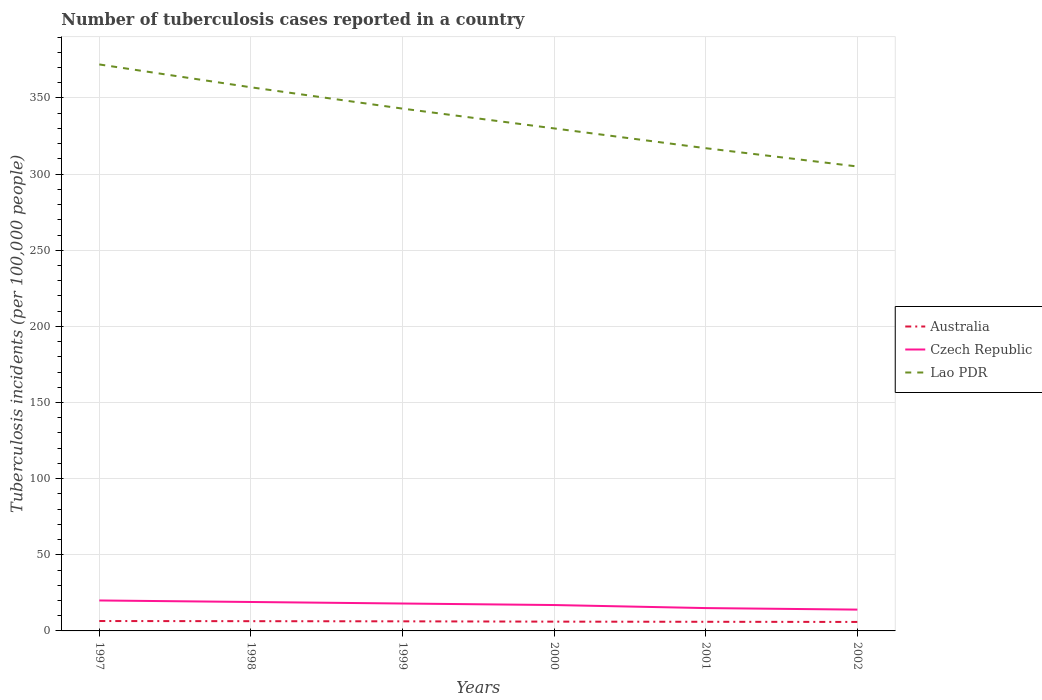Is the number of lines equal to the number of legend labels?
Your response must be concise. Yes. Across all years, what is the maximum number of tuberculosis cases reported in in Czech Republic?
Your answer should be very brief. 14. What is the total number of tuberculosis cases reported in in Australia in the graph?
Give a very brief answer. 0.2. What is the difference between the highest and the second highest number of tuberculosis cases reported in in Czech Republic?
Your answer should be compact. 6. How many years are there in the graph?
Keep it short and to the point. 6. What is the difference between two consecutive major ticks on the Y-axis?
Provide a succinct answer. 50. Where does the legend appear in the graph?
Your answer should be compact. Center right. How many legend labels are there?
Offer a very short reply. 3. How are the legend labels stacked?
Your answer should be compact. Vertical. What is the title of the graph?
Ensure brevity in your answer.  Number of tuberculosis cases reported in a country. Does "High income: OECD" appear as one of the legend labels in the graph?
Your answer should be very brief. No. What is the label or title of the X-axis?
Offer a very short reply. Years. What is the label or title of the Y-axis?
Give a very brief answer. Tuberculosis incidents (per 100,0 people). What is the Tuberculosis incidents (per 100,000 people) of Australia in 1997?
Keep it short and to the point. 6.5. What is the Tuberculosis incidents (per 100,000 people) in Lao PDR in 1997?
Your answer should be very brief. 372. What is the Tuberculosis incidents (per 100,000 people) of Lao PDR in 1998?
Provide a succinct answer. 357. What is the Tuberculosis incidents (per 100,000 people) of Australia in 1999?
Give a very brief answer. 6.3. What is the Tuberculosis incidents (per 100,000 people) in Czech Republic in 1999?
Offer a terse response. 18. What is the Tuberculosis incidents (per 100,000 people) of Lao PDR in 1999?
Offer a very short reply. 343. What is the Tuberculosis incidents (per 100,000 people) in Australia in 2000?
Ensure brevity in your answer.  6.1. What is the Tuberculosis incidents (per 100,000 people) of Lao PDR in 2000?
Your answer should be compact. 330. What is the Tuberculosis incidents (per 100,000 people) of Australia in 2001?
Your answer should be very brief. 6. What is the Tuberculosis incidents (per 100,000 people) of Lao PDR in 2001?
Give a very brief answer. 317. What is the Tuberculosis incidents (per 100,000 people) of Lao PDR in 2002?
Ensure brevity in your answer.  305. Across all years, what is the maximum Tuberculosis incidents (per 100,000 people) in Czech Republic?
Offer a terse response. 20. Across all years, what is the maximum Tuberculosis incidents (per 100,000 people) in Lao PDR?
Provide a short and direct response. 372. Across all years, what is the minimum Tuberculosis incidents (per 100,000 people) of Australia?
Your answer should be very brief. 5.9. Across all years, what is the minimum Tuberculosis incidents (per 100,000 people) in Czech Republic?
Provide a succinct answer. 14. Across all years, what is the minimum Tuberculosis incidents (per 100,000 people) of Lao PDR?
Give a very brief answer. 305. What is the total Tuberculosis incidents (per 100,000 people) in Australia in the graph?
Your answer should be very brief. 37.2. What is the total Tuberculosis incidents (per 100,000 people) of Czech Republic in the graph?
Ensure brevity in your answer.  103. What is the total Tuberculosis incidents (per 100,000 people) in Lao PDR in the graph?
Provide a succinct answer. 2024. What is the difference between the Tuberculosis incidents (per 100,000 people) of Australia in 1997 and that in 1998?
Offer a very short reply. 0.1. What is the difference between the Tuberculosis incidents (per 100,000 people) in Australia in 1997 and that in 1999?
Provide a succinct answer. 0.2. What is the difference between the Tuberculosis incidents (per 100,000 people) in Australia in 1997 and that in 2000?
Offer a very short reply. 0.4. What is the difference between the Tuberculosis incidents (per 100,000 people) of Czech Republic in 1997 and that in 2000?
Your response must be concise. 3. What is the difference between the Tuberculosis incidents (per 100,000 people) in Czech Republic in 1997 and that in 2001?
Make the answer very short. 5. What is the difference between the Tuberculosis incidents (per 100,000 people) in Lao PDR in 1997 and that in 2001?
Your response must be concise. 55. What is the difference between the Tuberculosis incidents (per 100,000 people) of Czech Republic in 1998 and that in 1999?
Your response must be concise. 1. What is the difference between the Tuberculosis incidents (per 100,000 people) of Australia in 1998 and that in 2000?
Offer a terse response. 0.3. What is the difference between the Tuberculosis incidents (per 100,000 people) of Czech Republic in 1998 and that in 2000?
Your response must be concise. 2. What is the difference between the Tuberculosis incidents (per 100,000 people) in Lao PDR in 1998 and that in 2000?
Give a very brief answer. 27. What is the difference between the Tuberculosis incidents (per 100,000 people) of Czech Republic in 1998 and that in 2001?
Make the answer very short. 4. What is the difference between the Tuberculosis incidents (per 100,000 people) in Lao PDR in 1998 and that in 2001?
Your answer should be compact. 40. What is the difference between the Tuberculosis incidents (per 100,000 people) of Australia in 1998 and that in 2002?
Provide a short and direct response. 0.5. What is the difference between the Tuberculosis incidents (per 100,000 people) of Czech Republic in 1998 and that in 2002?
Your response must be concise. 5. What is the difference between the Tuberculosis incidents (per 100,000 people) in Lao PDR in 1998 and that in 2002?
Keep it short and to the point. 52. What is the difference between the Tuberculosis incidents (per 100,000 people) in Australia in 1999 and that in 2001?
Keep it short and to the point. 0.3. What is the difference between the Tuberculosis incidents (per 100,000 people) in Czech Republic in 1999 and that in 2001?
Your answer should be very brief. 3. What is the difference between the Tuberculosis incidents (per 100,000 people) of Australia in 1999 and that in 2002?
Your response must be concise. 0.4. What is the difference between the Tuberculosis incidents (per 100,000 people) in Czech Republic in 1999 and that in 2002?
Give a very brief answer. 4. What is the difference between the Tuberculosis incidents (per 100,000 people) of Lao PDR in 1999 and that in 2002?
Keep it short and to the point. 38. What is the difference between the Tuberculosis incidents (per 100,000 people) in Australia in 2000 and that in 2002?
Provide a short and direct response. 0.2. What is the difference between the Tuberculosis incidents (per 100,000 people) in Australia in 2001 and that in 2002?
Provide a succinct answer. 0.1. What is the difference between the Tuberculosis incidents (per 100,000 people) in Czech Republic in 2001 and that in 2002?
Offer a terse response. 1. What is the difference between the Tuberculosis incidents (per 100,000 people) in Lao PDR in 2001 and that in 2002?
Ensure brevity in your answer.  12. What is the difference between the Tuberculosis incidents (per 100,000 people) in Australia in 1997 and the Tuberculosis incidents (per 100,000 people) in Lao PDR in 1998?
Your answer should be very brief. -350.5. What is the difference between the Tuberculosis incidents (per 100,000 people) of Czech Republic in 1997 and the Tuberculosis incidents (per 100,000 people) of Lao PDR in 1998?
Offer a very short reply. -337. What is the difference between the Tuberculosis incidents (per 100,000 people) in Australia in 1997 and the Tuberculosis incidents (per 100,000 people) in Lao PDR in 1999?
Keep it short and to the point. -336.5. What is the difference between the Tuberculosis incidents (per 100,000 people) in Czech Republic in 1997 and the Tuberculosis incidents (per 100,000 people) in Lao PDR in 1999?
Your answer should be very brief. -323. What is the difference between the Tuberculosis incidents (per 100,000 people) in Australia in 1997 and the Tuberculosis incidents (per 100,000 people) in Czech Republic in 2000?
Keep it short and to the point. -10.5. What is the difference between the Tuberculosis incidents (per 100,000 people) of Australia in 1997 and the Tuberculosis incidents (per 100,000 people) of Lao PDR in 2000?
Provide a succinct answer. -323.5. What is the difference between the Tuberculosis incidents (per 100,000 people) in Czech Republic in 1997 and the Tuberculosis incidents (per 100,000 people) in Lao PDR in 2000?
Keep it short and to the point. -310. What is the difference between the Tuberculosis incidents (per 100,000 people) of Australia in 1997 and the Tuberculosis incidents (per 100,000 people) of Lao PDR in 2001?
Provide a short and direct response. -310.5. What is the difference between the Tuberculosis incidents (per 100,000 people) of Czech Republic in 1997 and the Tuberculosis incidents (per 100,000 people) of Lao PDR in 2001?
Ensure brevity in your answer.  -297. What is the difference between the Tuberculosis incidents (per 100,000 people) in Australia in 1997 and the Tuberculosis incidents (per 100,000 people) in Czech Republic in 2002?
Keep it short and to the point. -7.5. What is the difference between the Tuberculosis incidents (per 100,000 people) in Australia in 1997 and the Tuberculosis incidents (per 100,000 people) in Lao PDR in 2002?
Your response must be concise. -298.5. What is the difference between the Tuberculosis incidents (per 100,000 people) in Czech Republic in 1997 and the Tuberculosis incidents (per 100,000 people) in Lao PDR in 2002?
Provide a short and direct response. -285. What is the difference between the Tuberculosis incidents (per 100,000 people) of Australia in 1998 and the Tuberculosis incidents (per 100,000 people) of Lao PDR in 1999?
Offer a terse response. -336.6. What is the difference between the Tuberculosis incidents (per 100,000 people) of Czech Republic in 1998 and the Tuberculosis incidents (per 100,000 people) of Lao PDR in 1999?
Provide a succinct answer. -324. What is the difference between the Tuberculosis incidents (per 100,000 people) in Australia in 1998 and the Tuberculosis incidents (per 100,000 people) in Lao PDR in 2000?
Offer a very short reply. -323.6. What is the difference between the Tuberculosis incidents (per 100,000 people) in Czech Republic in 1998 and the Tuberculosis incidents (per 100,000 people) in Lao PDR in 2000?
Provide a short and direct response. -311. What is the difference between the Tuberculosis incidents (per 100,000 people) of Australia in 1998 and the Tuberculosis incidents (per 100,000 people) of Lao PDR in 2001?
Your answer should be compact. -310.6. What is the difference between the Tuberculosis incidents (per 100,000 people) of Czech Republic in 1998 and the Tuberculosis incidents (per 100,000 people) of Lao PDR in 2001?
Keep it short and to the point. -298. What is the difference between the Tuberculosis incidents (per 100,000 people) of Australia in 1998 and the Tuberculosis incidents (per 100,000 people) of Lao PDR in 2002?
Provide a short and direct response. -298.6. What is the difference between the Tuberculosis incidents (per 100,000 people) of Czech Republic in 1998 and the Tuberculosis incidents (per 100,000 people) of Lao PDR in 2002?
Your answer should be very brief. -286. What is the difference between the Tuberculosis incidents (per 100,000 people) in Australia in 1999 and the Tuberculosis incidents (per 100,000 people) in Lao PDR in 2000?
Give a very brief answer. -323.7. What is the difference between the Tuberculosis incidents (per 100,000 people) of Czech Republic in 1999 and the Tuberculosis incidents (per 100,000 people) of Lao PDR in 2000?
Offer a terse response. -312. What is the difference between the Tuberculosis incidents (per 100,000 people) in Australia in 1999 and the Tuberculosis incidents (per 100,000 people) in Lao PDR in 2001?
Provide a short and direct response. -310.7. What is the difference between the Tuberculosis incidents (per 100,000 people) in Czech Republic in 1999 and the Tuberculosis incidents (per 100,000 people) in Lao PDR in 2001?
Keep it short and to the point. -299. What is the difference between the Tuberculosis incidents (per 100,000 people) of Australia in 1999 and the Tuberculosis incidents (per 100,000 people) of Czech Republic in 2002?
Your answer should be compact. -7.7. What is the difference between the Tuberculosis incidents (per 100,000 people) of Australia in 1999 and the Tuberculosis incidents (per 100,000 people) of Lao PDR in 2002?
Keep it short and to the point. -298.7. What is the difference between the Tuberculosis incidents (per 100,000 people) of Czech Republic in 1999 and the Tuberculosis incidents (per 100,000 people) of Lao PDR in 2002?
Offer a very short reply. -287. What is the difference between the Tuberculosis incidents (per 100,000 people) in Australia in 2000 and the Tuberculosis incidents (per 100,000 people) in Czech Republic in 2001?
Keep it short and to the point. -8.9. What is the difference between the Tuberculosis incidents (per 100,000 people) of Australia in 2000 and the Tuberculosis incidents (per 100,000 people) of Lao PDR in 2001?
Your response must be concise. -310.9. What is the difference between the Tuberculosis incidents (per 100,000 people) in Czech Republic in 2000 and the Tuberculosis incidents (per 100,000 people) in Lao PDR in 2001?
Keep it short and to the point. -300. What is the difference between the Tuberculosis incidents (per 100,000 people) of Australia in 2000 and the Tuberculosis incidents (per 100,000 people) of Czech Republic in 2002?
Keep it short and to the point. -7.9. What is the difference between the Tuberculosis incidents (per 100,000 people) in Australia in 2000 and the Tuberculosis incidents (per 100,000 people) in Lao PDR in 2002?
Keep it short and to the point. -298.9. What is the difference between the Tuberculosis incidents (per 100,000 people) in Czech Republic in 2000 and the Tuberculosis incidents (per 100,000 people) in Lao PDR in 2002?
Your response must be concise. -288. What is the difference between the Tuberculosis incidents (per 100,000 people) in Australia in 2001 and the Tuberculosis incidents (per 100,000 people) in Lao PDR in 2002?
Make the answer very short. -299. What is the difference between the Tuberculosis incidents (per 100,000 people) in Czech Republic in 2001 and the Tuberculosis incidents (per 100,000 people) in Lao PDR in 2002?
Offer a terse response. -290. What is the average Tuberculosis incidents (per 100,000 people) of Czech Republic per year?
Your answer should be compact. 17.17. What is the average Tuberculosis incidents (per 100,000 people) in Lao PDR per year?
Make the answer very short. 337.33. In the year 1997, what is the difference between the Tuberculosis incidents (per 100,000 people) in Australia and Tuberculosis incidents (per 100,000 people) in Lao PDR?
Offer a terse response. -365.5. In the year 1997, what is the difference between the Tuberculosis incidents (per 100,000 people) of Czech Republic and Tuberculosis incidents (per 100,000 people) of Lao PDR?
Provide a short and direct response. -352. In the year 1998, what is the difference between the Tuberculosis incidents (per 100,000 people) of Australia and Tuberculosis incidents (per 100,000 people) of Lao PDR?
Ensure brevity in your answer.  -350.6. In the year 1998, what is the difference between the Tuberculosis incidents (per 100,000 people) of Czech Republic and Tuberculosis incidents (per 100,000 people) of Lao PDR?
Keep it short and to the point. -338. In the year 1999, what is the difference between the Tuberculosis incidents (per 100,000 people) in Australia and Tuberculosis incidents (per 100,000 people) in Lao PDR?
Your response must be concise. -336.7. In the year 1999, what is the difference between the Tuberculosis incidents (per 100,000 people) of Czech Republic and Tuberculosis incidents (per 100,000 people) of Lao PDR?
Provide a succinct answer. -325. In the year 2000, what is the difference between the Tuberculosis incidents (per 100,000 people) of Australia and Tuberculosis incidents (per 100,000 people) of Lao PDR?
Give a very brief answer. -323.9. In the year 2000, what is the difference between the Tuberculosis incidents (per 100,000 people) of Czech Republic and Tuberculosis incidents (per 100,000 people) of Lao PDR?
Your answer should be compact. -313. In the year 2001, what is the difference between the Tuberculosis incidents (per 100,000 people) in Australia and Tuberculosis incidents (per 100,000 people) in Lao PDR?
Offer a very short reply. -311. In the year 2001, what is the difference between the Tuberculosis incidents (per 100,000 people) in Czech Republic and Tuberculosis incidents (per 100,000 people) in Lao PDR?
Give a very brief answer. -302. In the year 2002, what is the difference between the Tuberculosis incidents (per 100,000 people) in Australia and Tuberculosis incidents (per 100,000 people) in Lao PDR?
Provide a succinct answer. -299.1. In the year 2002, what is the difference between the Tuberculosis incidents (per 100,000 people) of Czech Republic and Tuberculosis incidents (per 100,000 people) of Lao PDR?
Make the answer very short. -291. What is the ratio of the Tuberculosis incidents (per 100,000 people) in Australia in 1997 to that in 1998?
Your response must be concise. 1.02. What is the ratio of the Tuberculosis incidents (per 100,000 people) of Czech Republic in 1997 to that in 1998?
Provide a succinct answer. 1.05. What is the ratio of the Tuberculosis incidents (per 100,000 people) of Lao PDR in 1997 to that in 1998?
Your answer should be very brief. 1.04. What is the ratio of the Tuberculosis incidents (per 100,000 people) of Australia in 1997 to that in 1999?
Ensure brevity in your answer.  1.03. What is the ratio of the Tuberculosis incidents (per 100,000 people) in Czech Republic in 1997 to that in 1999?
Your answer should be very brief. 1.11. What is the ratio of the Tuberculosis incidents (per 100,000 people) in Lao PDR in 1997 to that in 1999?
Keep it short and to the point. 1.08. What is the ratio of the Tuberculosis incidents (per 100,000 people) in Australia in 1997 to that in 2000?
Make the answer very short. 1.07. What is the ratio of the Tuberculosis incidents (per 100,000 people) in Czech Republic in 1997 to that in 2000?
Offer a terse response. 1.18. What is the ratio of the Tuberculosis incidents (per 100,000 people) of Lao PDR in 1997 to that in 2000?
Offer a very short reply. 1.13. What is the ratio of the Tuberculosis incidents (per 100,000 people) of Australia in 1997 to that in 2001?
Provide a short and direct response. 1.08. What is the ratio of the Tuberculosis incidents (per 100,000 people) of Czech Republic in 1997 to that in 2001?
Your response must be concise. 1.33. What is the ratio of the Tuberculosis incidents (per 100,000 people) of Lao PDR in 1997 to that in 2001?
Keep it short and to the point. 1.17. What is the ratio of the Tuberculosis incidents (per 100,000 people) of Australia in 1997 to that in 2002?
Offer a terse response. 1.1. What is the ratio of the Tuberculosis incidents (per 100,000 people) of Czech Republic in 1997 to that in 2002?
Provide a succinct answer. 1.43. What is the ratio of the Tuberculosis incidents (per 100,000 people) of Lao PDR in 1997 to that in 2002?
Your answer should be very brief. 1.22. What is the ratio of the Tuberculosis incidents (per 100,000 people) of Australia in 1998 to that in 1999?
Your answer should be very brief. 1.02. What is the ratio of the Tuberculosis incidents (per 100,000 people) in Czech Republic in 1998 to that in 1999?
Your answer should be very brief. 1.06. What is the ratio of the Tuberculosis incidents (per 100,000 people) of Lao PDR in 1998 to that in 1999?
Provide a succinct answer. 1.04. What is the ratio of the Tuberculosis incidents (per 100,000 people) of Australia in 1998 to that in 2000?
Ensure brevity in your answer.  1.05. What is the ratio of the Tuberculosis incidents (per 100,000 people) in Czech Republic in 1998 to that in 2000?
Give a very brief answer. 1.12. What is the ratio of the Tuberculosis incidents (per 100,000 people) of Lao PDR in 1998 to that in 2000?
Your answer should be compact. 1.08. What is the ratio of the Tuberculosis incidents (per 100,000 people) of Australia in 1998 to that in 2001?
Ensure brevity in your answer.  1.07. What is the ratio of the Tuberculosis incidents (per 100,000 people) in Czech Republic in 1998 to that in 2001?
Ensure brevity in your answer.  1.27. What is the ratio of the Tuberculosis incidents (per 100,000 people) in Lao PDR in 1998 to that in 2001?
Offer a very short reply. 1.13. What is the ratio of the Tuberculosis incidents (per 100,000 people) in Australia in 1998 to that in 2002?
Offer a terse response. 1.08. What is the ratio of the Tuberculosis incidents (per 100,000 people) of Czech Republic in 1998 to that in 2002?
Your answer should be very brief. 1.36. What is the ratio of the Tuberculosis incidents (per 100,000 people) in Lao PDR in 1998 to that in 2002?
Offer a terse response. 1.17. What is the ratio of the Tuberculosis incidents (per 100,000 people) of Australia in 1999 to that in 2000?
Offer a terse response. 1.03. What is the ratio of the Tuberculosis incidents (per 100,000 people) in Czech Republic in 1999 to that in 2000?
Offer a very short reply. 1.06. What is the ratio of the Tuberculosis incidents (per 100,000 people) of Lao PDR in 1999 to that in 2000?
Your answer should be compact. 1.04. What is the ratio of the Tuberculosis incidents (per 100,000 people) in Lao PDR in 1999 to that in 2001?
Your answer should be compact. 1.08. What is the ratio of the Tuberculosis incidents (per 100,000 people) of Australia in 1999 to that in 2002?
Provide a succinct answer. 1.07. What is the ratio of the Tuberculosis incidents (per 100,000 people) in Czech Republic in 1999 to that in 2002?
Your answer should be compact. 1.29. What is the ratio of the Tuberculosis incidents (per 100,000 people) in Lao PDR in 1999 to that in 2002?
Offer a very short reply. 1.12. What is the ratio of the Tuberculosis incidents (per 100,000 people) in Australia in 2000 to that in 2001?
Make the answer very short. 1.02. What is the ratio of the Tuberculosis incidents (per 100,000 people) of Czech Republic in 2000 to that in 2001?
Your answer should be compact. 1.13. What is the ratio of the Tuberculosis incidents (per 100,000 people) of Lao PDR in 2000 to that in 2001?
Your answer should be compact. 1.04. What is the ratio of the Tuberculosis incidents (per 100,000 people) of Australia in 2000 to that in 2002?
Your response must be concise. 1.03. What is the ratio of the Tuberculosis incidents (per 100,000 people) of Czech Republic in 2000 to that in 2002?
Offer a very short reply. 1.21. What is the ratio of the Tuberculosis incidents (per 100,000 people) in Lao PDR in 2000 to that in 2002?
Your answer should be compact. 1.08. What is the ratio of the Tuberculosis incidents (per 100,000 people) of Australia in 2001 to that in 2002?
Your answer should be very brief. 1.02. What is the ratio of the Tuberculosis incidents (per 100,000 people) of Czech Republic in 2001 to that in 2002?
Your response must be concise. 1.07. What is the ratio of the Tuberculosis incidents (per 100,000 people) of Lao PDR in 2001 to that in 2002?
Make the answer very short. 1.04. What is the difference between the highest and the second highest Tuberculosis incidents (per 100,000 people) in Czech Republic?
Keep it short and to the point. 1. What is the difference between the highest and the lowest Tuberculosis incidents (per 100,000 people) of Australia?
Offer a terse response. 0.6. What is the difference between the highest and the lowest Tuberculosis incidents (per 100,000 people) of Lao PDR?
Give a very brief answer. 67. 